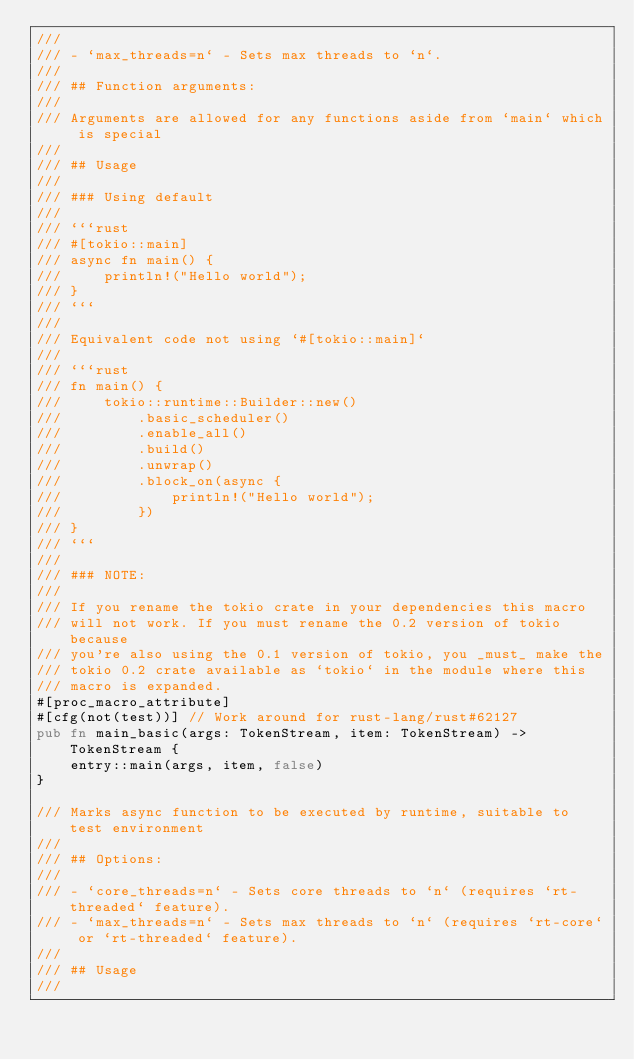Convert code to text. <code><loc_0><loc_0><loc_500><loc_500><_Rust_>///
/// - `max_threads=n` - Sets max threads to `n`.
///
/// ## Function arguments:
///
/// Arguments are allowed for any functions aside from `main` which is special
///
/// ## Usage
///
/// ### Using default
///
/// ```rust
/// #[tokio::main]
/// async fn main() {
///     println!("Hello world");
/// }
/// ```
///
/// Equivalent code not using `#[tokio::main]`
///
/// ```rust
/// fn main() {
///     tokio::runtime::Builder::new()
///         .basic_scheduler()
///         .enable_all()
///         .build()
///         .unwrap()
///         .block_on(async {
///             println!("Hello world");
///         })
/// }
/// ```
///
/// ### NOTE:
///
/// If you rename the tokio crate in your dependencies this macro
/// will not work. If you must rename the 0.2 version of tokio because
/// you're also using the 0.1 version of tokio, you _must_ make the
/// tokio 0.2 crate available as `tokio` in the module where this
/// macro is expanded.
#[proc_macro_attribute]
#[cfg(not(test))] // Work around for rust-lang/rust#62127
pub fn main_basic(args: TokenStream, item: TokenStream) -> TokenStream {
    entry::main(args, item, false)
}

/// Marks async function to be executed by runtime, suitable to test environment
///
/// ## Options:
///
/// - `core_threads=n` - Sets core threads to `n` (requires `rt-threaded` feature).
/// - `max_threads=n` - Sets max threads to `n` (requires `rt-core` or `rt-threaded` feature).
///
/// ## Usage
///</code> 